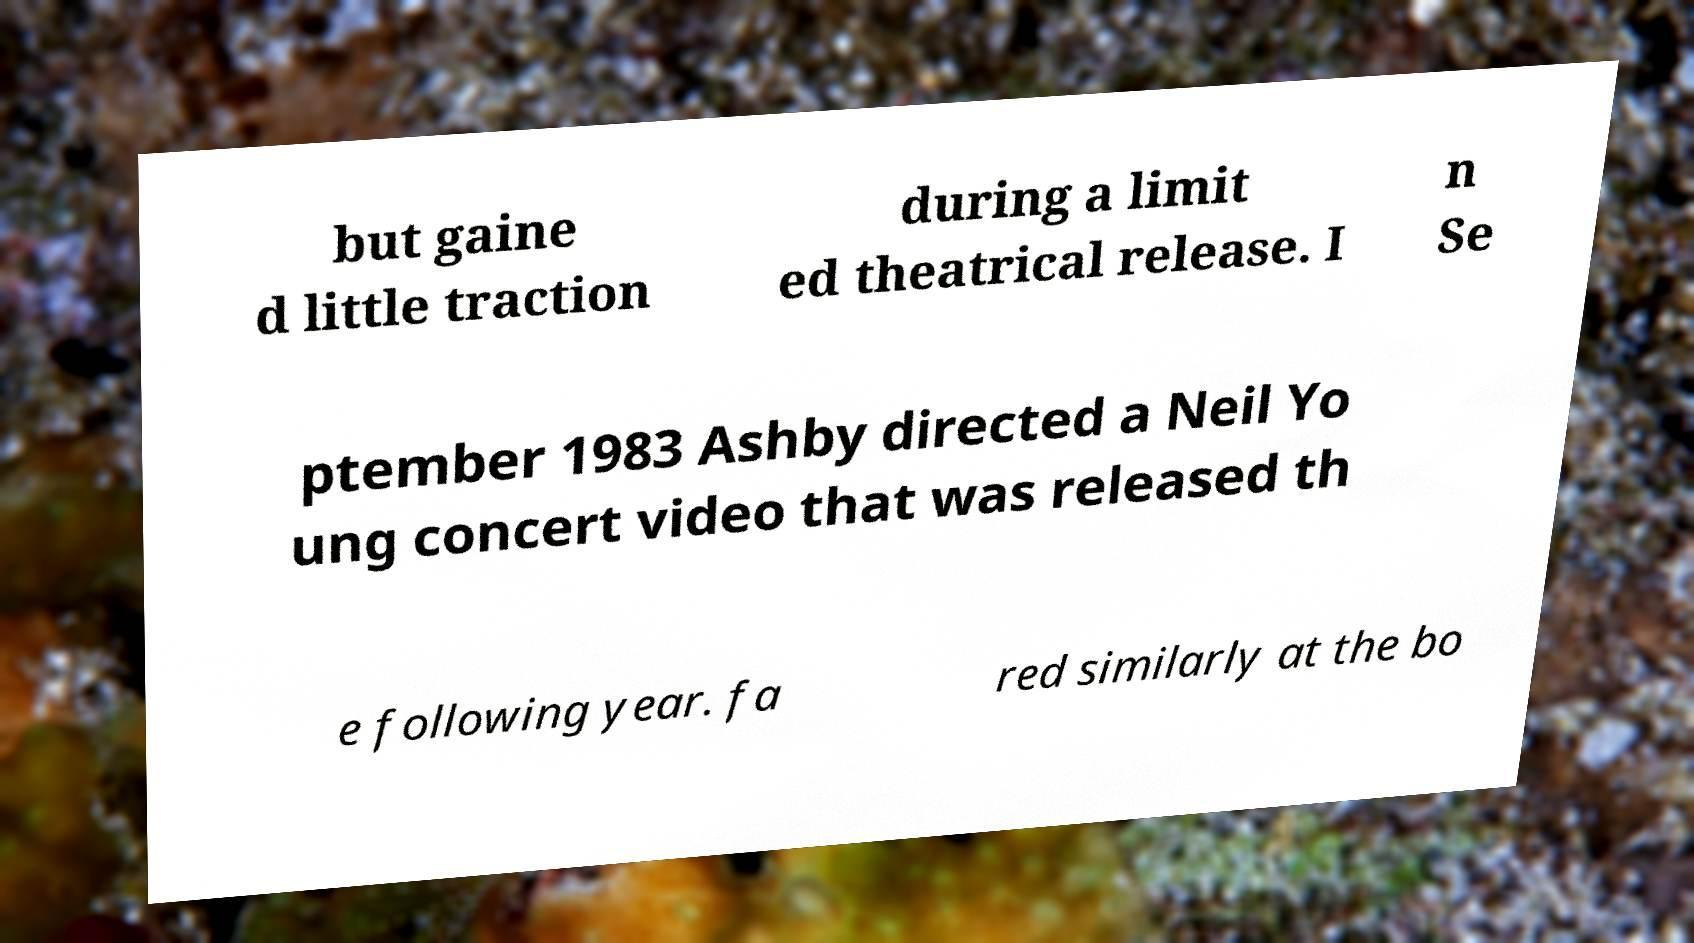There's text embedded in this image that I need extracted. Can you transcribe it verbatim? but gaine d little traction during a limit ed theatrical release. I n Se ptember 1983 Ashby directed a Neil Yo ung concert video that was released th e following year. fa red similarly at the bo 